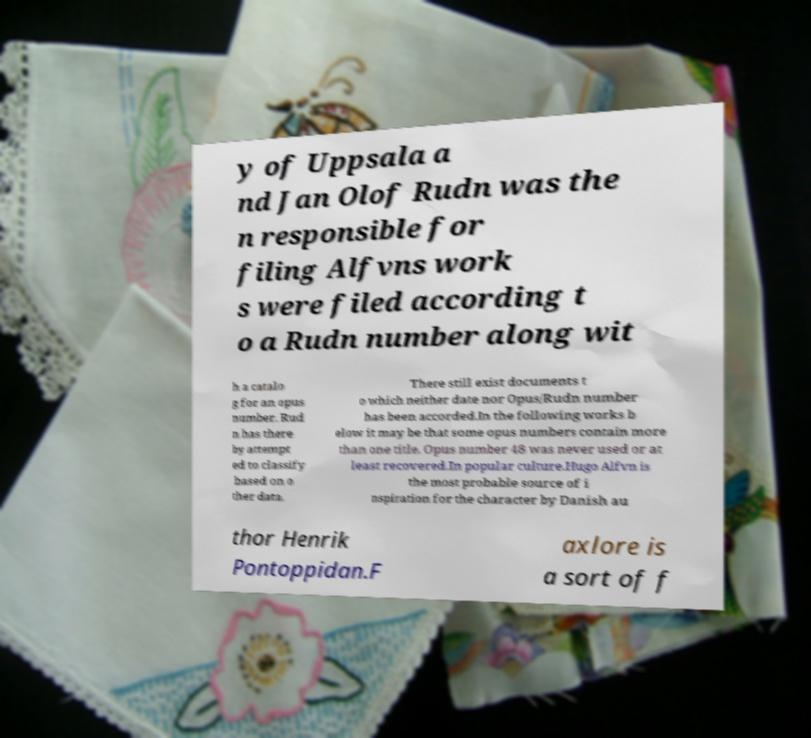Can you accurately transcribe the text from the provided image for me? y of Uppsala a nd Jan Olof Rudn was the n responsible for filing Alfvns work s were filed according t o a Rudn number along wit h a catalo g for an opus number. Rud n has there by attempt ed to classify based on o ther data. There still exist documents t o which neither date nor Opus/Rudn number has been accorded.In the following works b elow it may be that some opus numbers contain more than one title. Opus number 48 was never used or at least recovered.In popular culture.Hugo Alfvn is the most probable source of i nspiration for the character by Danish au thor Henrik Pontoppidan.F axlore is a sort of f 